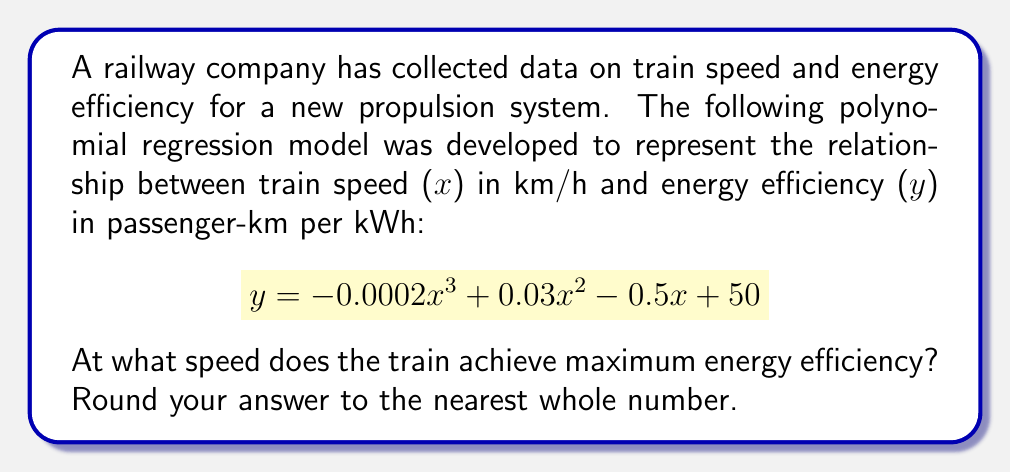Can you answer this question? To find the speed at which the train achieves maximum energy efficiency, we need to follow these steps:

1) The maximum point of the function occurs where its derivative equals zero. Let's find the derivative of the given function:

   $$\frac{dy}{dx} = -0.0006x^2 + 0.06x - 0.5$$

2) Set the derivative equal to zero and solve for x:

   $$-0.0006x^2 + 0.06x - 0.5 = 0$$

3) This is a quadratic equation. We can solve it using the quadratic formula:

   $$x = \frac{-b \pm \sqrt{b^2 - 4ac}}{2a}$$

   Where $a = -0.0006$, $b = 0.06$, and $c = -0.5$

4) Substituting these values:

   $$x = \frac{-0.06 \pm \sqrt{0.06^2 - 4(-0.0006)(-0.5)}}{2(-0.0006)}$$

5) Simplifying:

   $$x = \frac{-0.06 \pm \sqrt{0.0036 - 0.0012}}{-0.0012}$$
   $$x = \frac{-0.06 \pm \sqrt{0.0024}}{-0.0012}$$
   $$x = \frac{-0.06 \pm 0.048989795}{-0.0012}$$

6) This gives us two solutions:

   $$x_1 = \frac{-0.06 + 0.048989795}{-0.0012} \approx 91.67$$
   $$x_2 = \frac{-0.06 - 0.048989795}{-0.0012} \approx 8.33$$

7) To determine which of these is the maximum (rather than the minimum), we can check the second derivative:

   $$\frac{d^2y}{dx^2} = -0.0012x + 0.06$$

   At $x = 91.67$, this is negative, indicating a maximum.

8) Rounding to the nearest whole number:

   91.67 ≈ 92
Answer: 92 km/h 